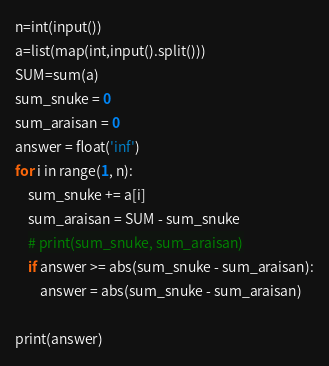Convert code to text. <code><loc_0><loc_0><loc_500><loc_500><_Python_>n=int(input())
a=list(map(int,input().split()))
SUM=sum(a)
sum_snuke = 0
sum_araisan = 0
answer = float('inf')
for i in range(1, n):
    sum_snuke += a[i]
    sum_araisan = SUM - sum_snuke
    # print(sum_snuke, sum_araisan)
    if answer >= abs(sum_snuke - sum_araisan):
        answer = abs(sum_snuke - sum_araisan)

print(answer)</code> 